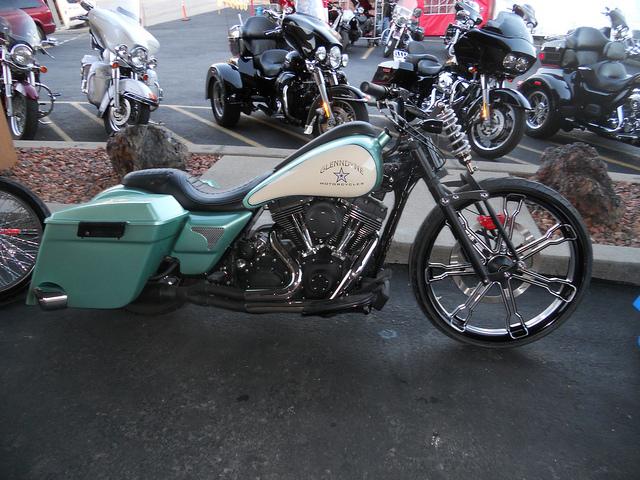Is there a person in the picture?
Concise answer only. No. What color are the rims on the motorcycle in front?
Quick response, please. Silver. Other than black, what color is the motorcycle?
Short answer required. Green. How many people can ride this bike at the same time?
Write a very short answer. 2. Is there a star on the motorcycle?
Keep it brief. Yes. How many bikes are there?
Write a very short answer. 11. Where are the motorcycles?
Be succinct. Parking lot. Is there a red motorcycle in the picture?
Keep it brief. No. What is the primary difference between the motorcycles?
Give a very brief answer. Color. How many motorcycles are there?
Keep it brief. 10. Is there a place on the bike to carry things?
Give a very brief answer. Yes. What color is the motorcycle?
Quick response, please. Teal. 